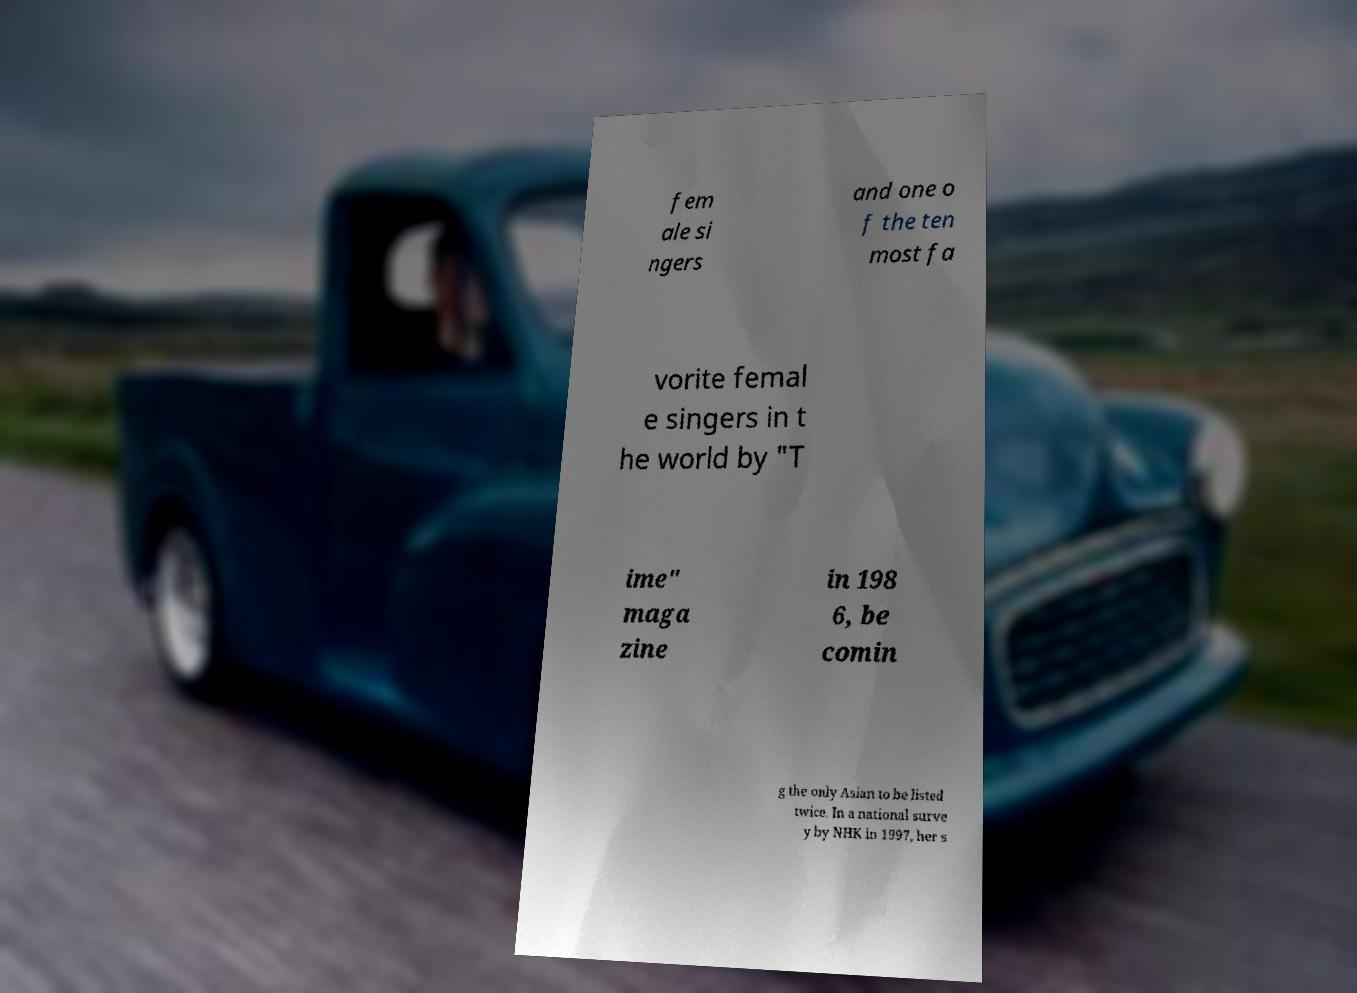Please read and relay the text visible in this image. What does it say? fem ale si ngers and one o f the ten most fa vorite femal e singers in t he world by "T ime" maga zine in 198 6, be comin g the only Asian to be listed twice. In a national surve y by NHK in 1997, her s 